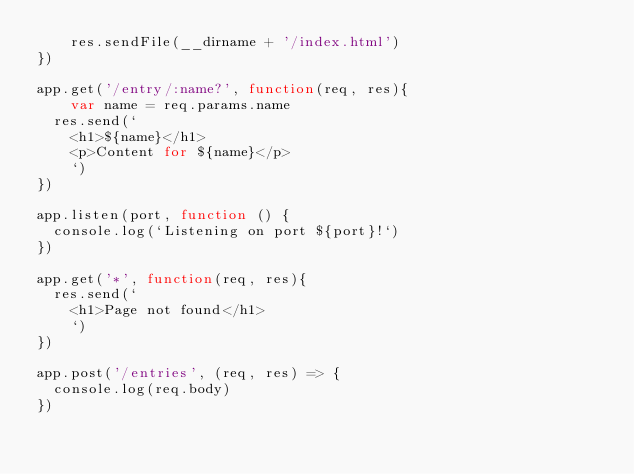Convert code to text. <code><loc_0><loc_0><loc_500><loc_500><_JavaScript_>	res.sendFile(__dirname + '/index.html')
})

app.get('/entry/:name?', function(req, res){
	var name = req.params.name
  res.send(`
    <h1>${name}</h1>
    <p>Content for ${name}</p>
    `)
})

app.listen(port, function () {
  console.log(`Listening on port ${port}!`)
})

app.get('*', function(req, res){
  res.send(`
    <h1>Page not found</h1>
    `)
})

app.post('/entries', (req, res) => {
  console.log(req.body)
})</code> 